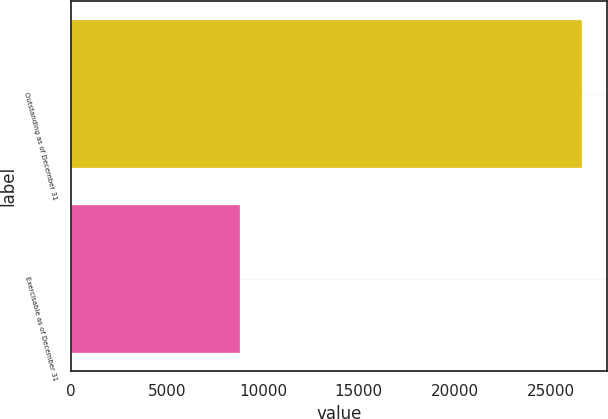Convert chart to OTSL. <chart><loc_0><loc_0><loc_500><loc_500><bar_chart><fcel>Outstanding as of December 31<fcel>Exercisable as of December 31<nl><fcel>26611<fcel>8815.3<nl></chart> 